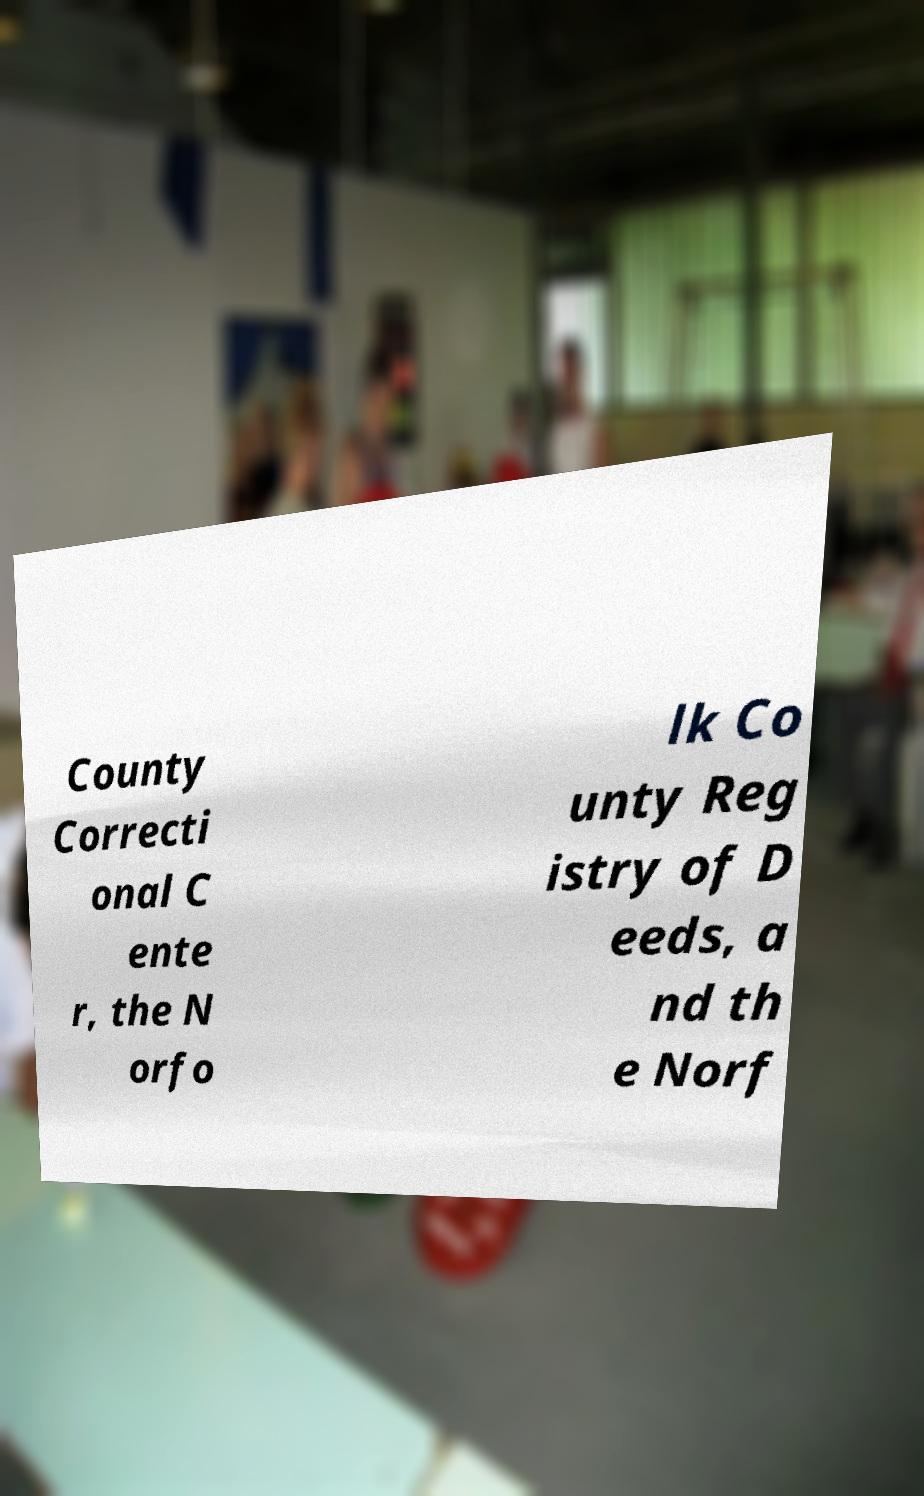Could you assist in decoding the text presented in this image and type it out clearly? County Correcti onal C ente r, the N orfo lk Co unty Reg istry of D eeds, a nd th e Norf 